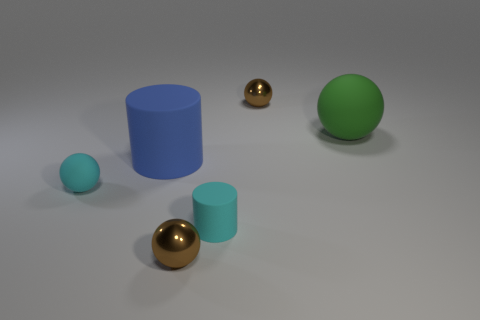Subtract all big rubber spheres. How many spheres are left? 3 Subtract all blue cubes. How many brown spheres are left? 2 Subtract all cyan balls. How many balls are left? 3 Subtract 1 balls. How many balls are left? 3 Subtract all purple spheres. Subtract all yellow cylinders. How many spheres are left? 4 Add 2 gray metallic cylinders. How many objects exist? 8 Subtract all cylinders. How many objects are left? 4 Add 1 cyan rubber spheres. How many cyan rubber spheres exist? 2 Subtract 0 purple cubes. How many objects are left? 6 Subtract all yellow matte cylinders. Subtract all big blue rubber cylinders. How many objects are left? 5 